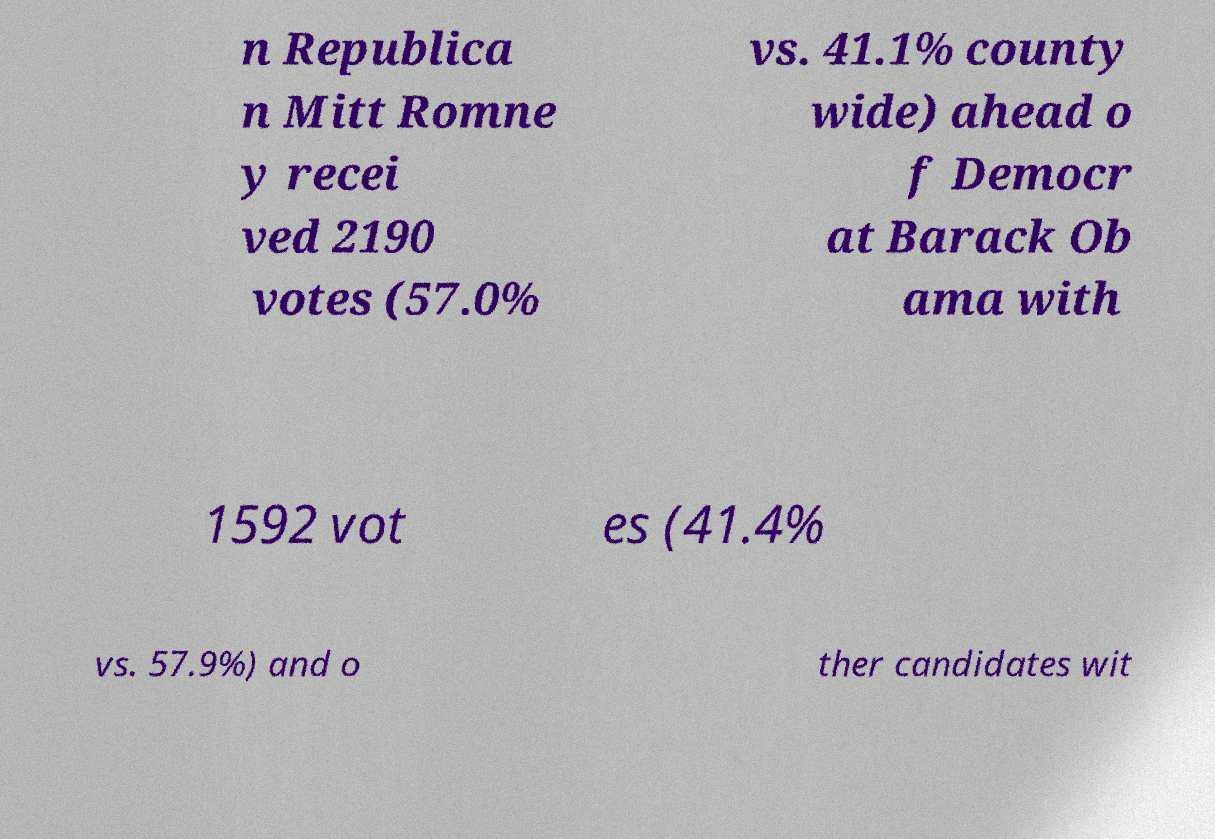Please read and relay the text visible in this image. What does it say? n Republica n Mitt Romne y recei ved 2190 votes (57.0% vs. 41.1% county wide) ahead o f Democr at Barack Ob ama with 1592 vot es (41.4% vs. 57.9%) and o ther candidates wit 